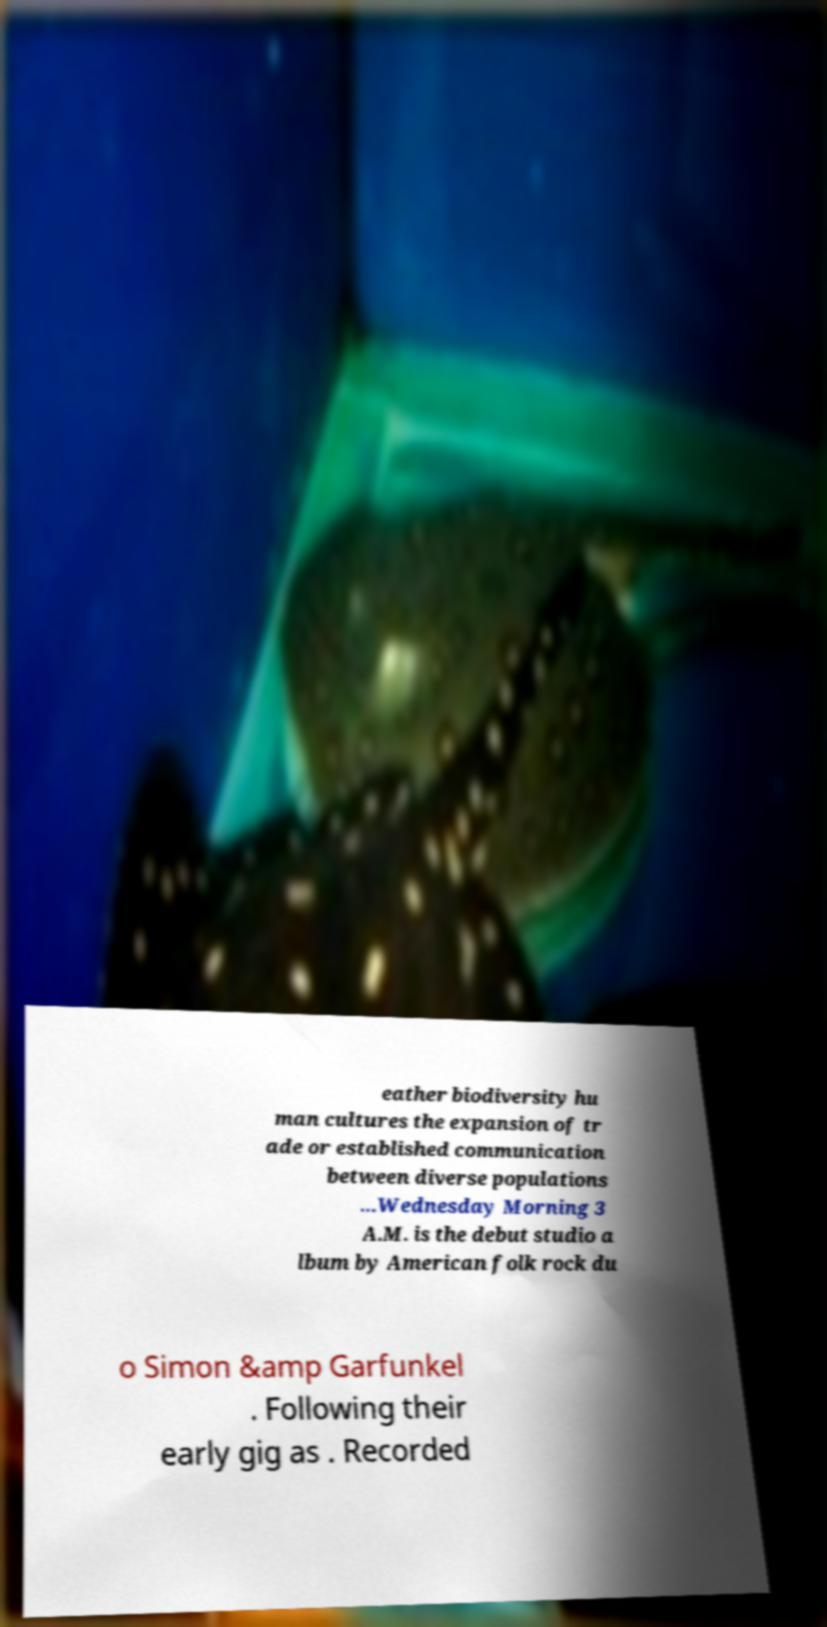Can you read and provide the text displayed in the image?This photo seems to have some interesting text. Can you extract and type it out for me? eather biodiversity hu man cultures the expansion of tr ade or established communication between diverse populations ...Wednesday Morning 3 A.M. is the debut studio a lbum by American folk rock du o Simon &amp Garfunkel . Following their early gig as . Recorded 